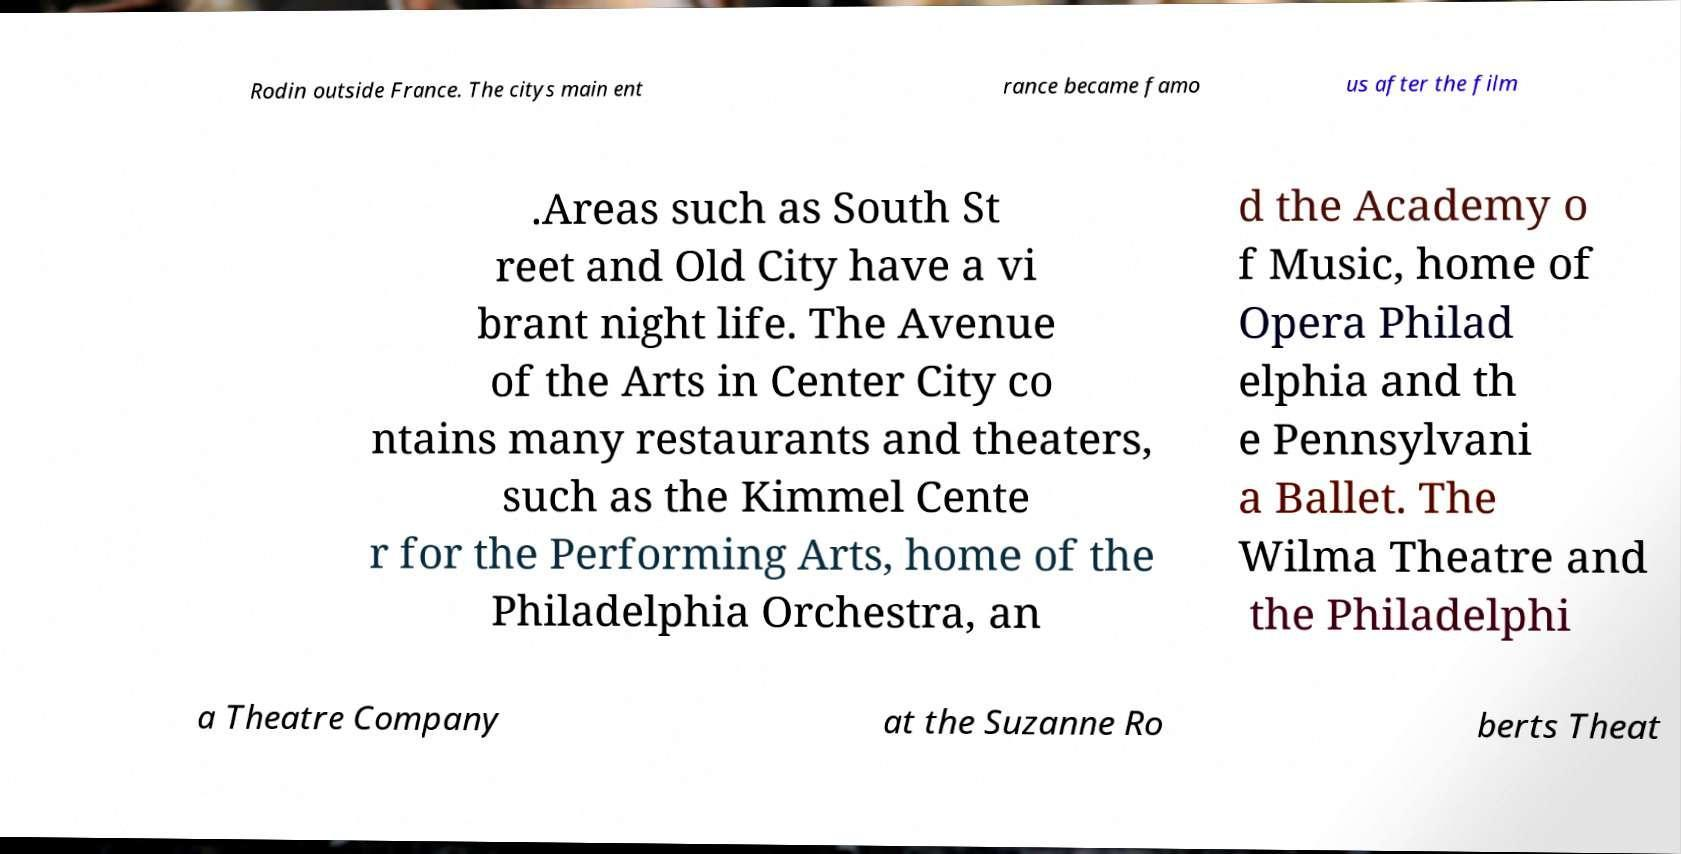Can you read and provide the text displayed in the image?This photo seems to have some interesting text. Can you extract and type it out for me? Rodin outside France. The citys main ent rance became famo us after the film .Areas such as South St reet and Old City have a vi brant night life. The Avenue of the Arts in Center City co ntains many restaurants and theaters, such as the Kimmel Cente r for the Performing Arts, home of the Philadelphia Orchestra, an d the Academy o f Music, home of Opera Philad elphia and th e Pennsylvani a Ballet. The Wilma Theatre and the Philadelphi a Theatre Company at the Suzanne Ro berts Theat 